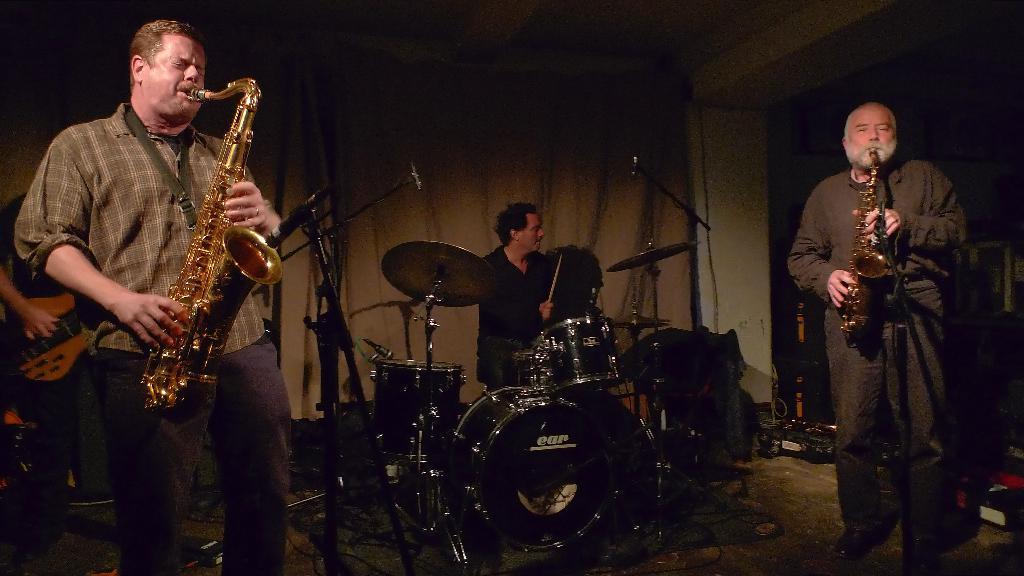Can you describe this image briefly? Here there are few persons on the floor are performing by playing musical instruments and we can see mics on a stand. In the background there is a curtain,wall and other objects. 